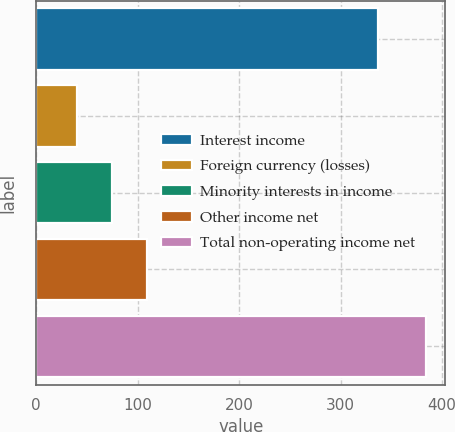Convert chart. <chart><loc_0><loc_0><loc_500><loc_500><bar_chart><fcel>Interest income<fcel>Foreign currency (losses)<fcel>Minority interests in income<fcel>Other income net<fcel>Total non-operating income net<nl><fcel>337<fcel>40<fcel>74.4<fcel>108.8<fcel>384<nl></chart> 